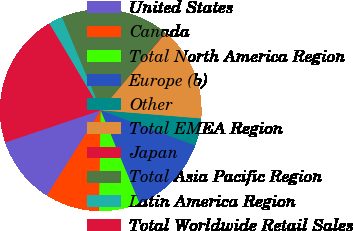Convert chart to OTSL. <chart><loc_0><loc_0><loc_500><loc_500><pie_chart><fcel>United States<fcel>Canada<fcel>Total North America Region<fcel>Europe (b)<fcel>Other<fcel>Total EMEA Region<fcel>Japan<fcel>Total Asia Pacific Region<fcel>Latin America Region<fcel>Total Worldwide Retail Sales<nl><fcel>10.86%<fcel>8.71%<fcel>6.55%<fcel>13.02%<fcel>4.39%<fcel>15.18%<fcel>0.07%<fcel>17.34%<fcel>2.23%<fcel>21.65%<nl></chart> 